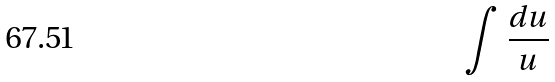<formula> <loc_0><loc_0><loc_500><loc_500>\int \frac { d u } { u }</formula> 